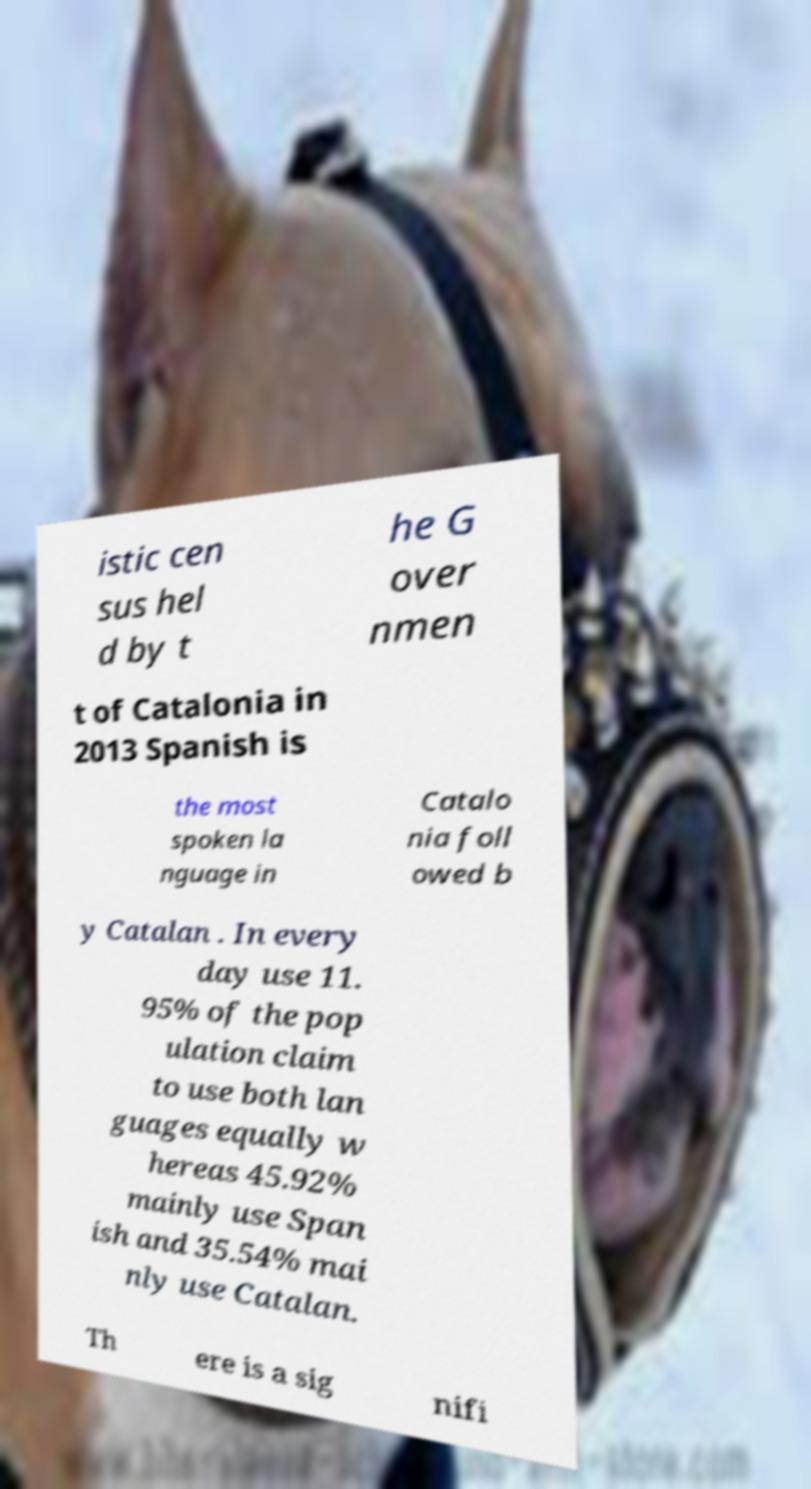There's text embedded in this image that I need extracted. Can you transcribe it verbatim? istic cen sus hel d by t he G over nmen t of Catalonia in 2013 Spanish is the most spoken la nguage in Catalo nia foll owed b y Catalan . In every day use 11. 95% of the pop ulation claim to use both lan guages equally w hereas 45.92% mainly use Span ish and 35.54% mai nly use Catalan. Th ere is a sig nifi 